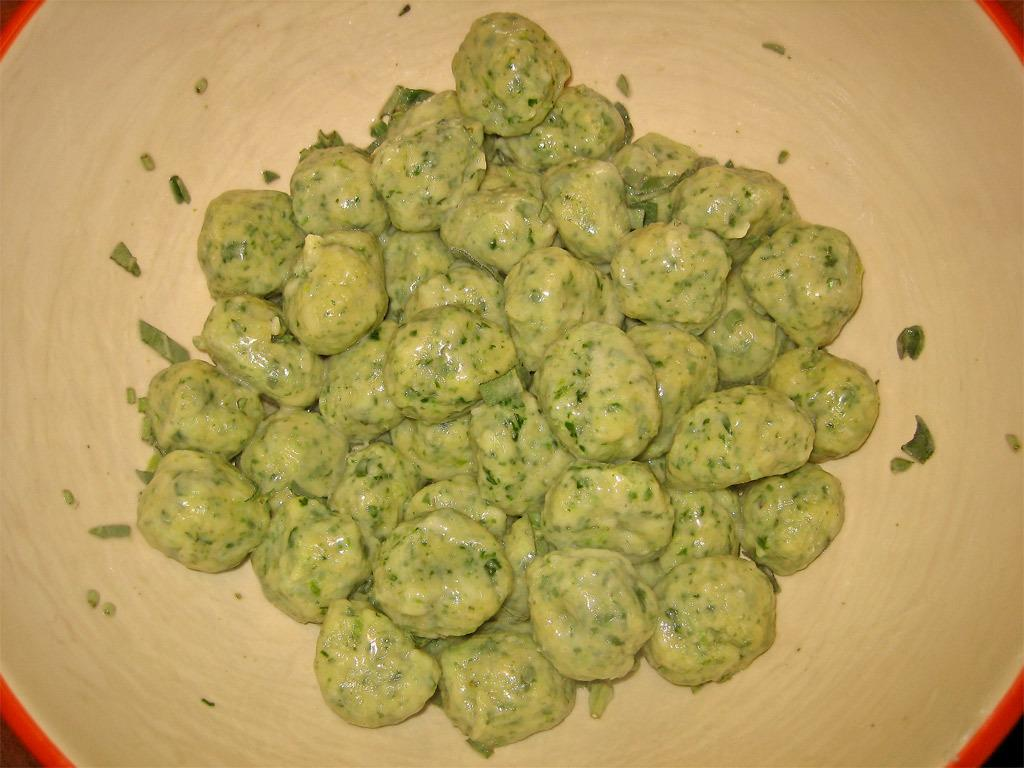What object is present in the image? There is a bowl in the image. What colors are used for the bowl? The bowl is orange and cream in color. What is inside the bowl? There is a food item in the bowl. What colors are used for the food item? The food item is cream and green in color. What type of robin can be seen singing in the image? There is no robin present in the image, and no music or singing is depicted. 